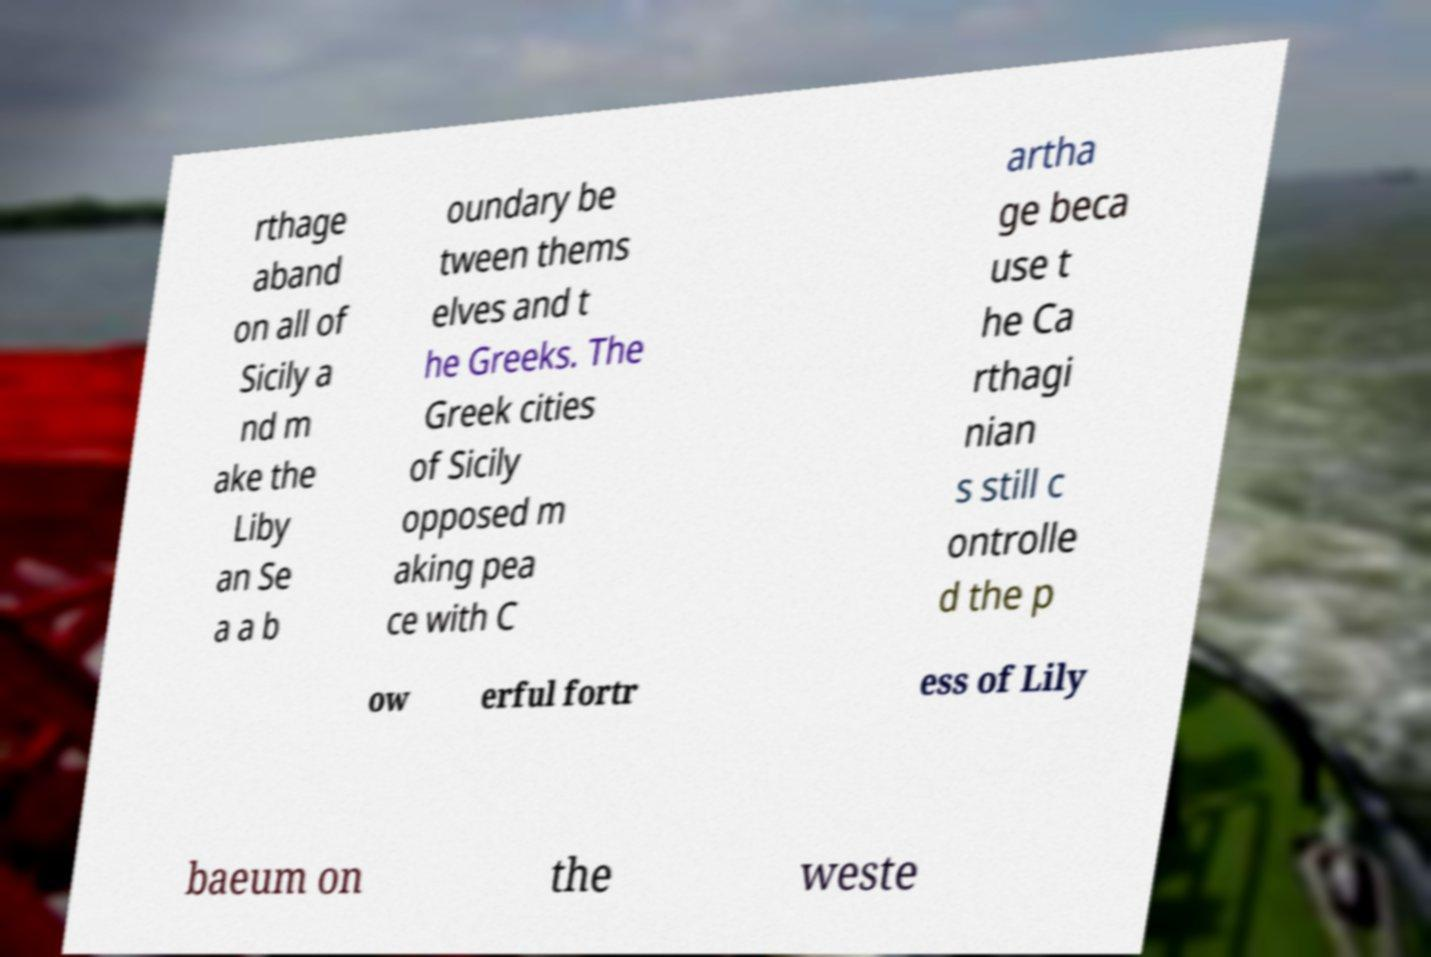There's text embedded in this image that I need extracted. Can you transcribe it verbatim? rthage aband on all of Sicily a nd m ake the Liby an Se a a b oundary be tween thems elves and t he Greeks. The Greek cities of Sicily opposed m aking pea ce with C artha ge beca use t he Ca rthagi nian s still c ontrolle d the p ow erful fortr ess of Lily baeum on the weste 